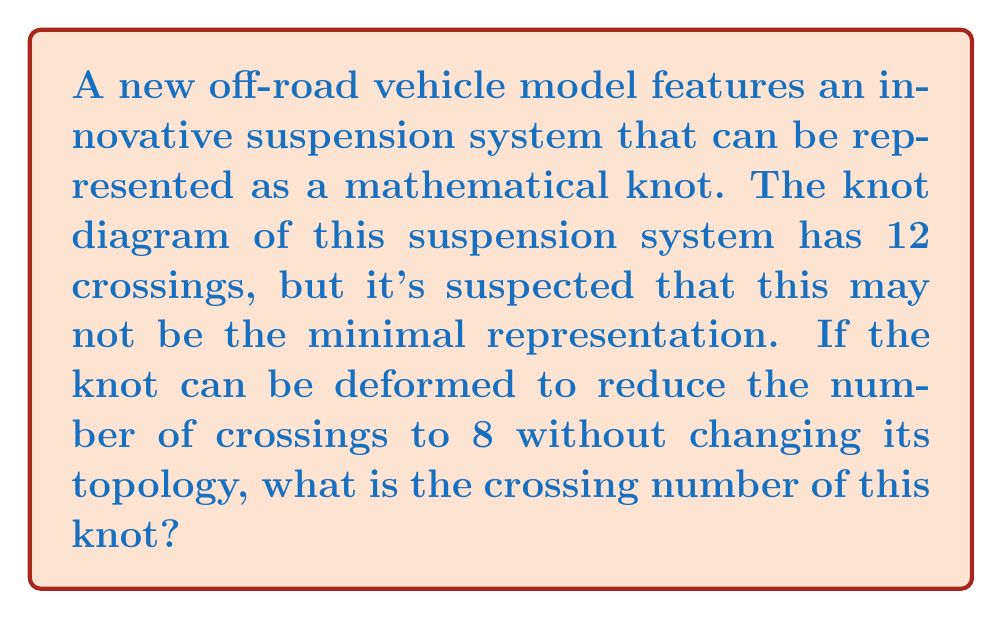Teach me how to tackle this problem. To determine the crossing number of the knot representing the off-road vehicle's suspension system, we need to follow these steps:

1. Understand the definition of crossing number:
   The crossing number of a knot is the minimum number of crossings that occur in any projection of the knot onto a plane.

2. Analyze the given information:
   - The initial knot diagram has 12 crossings.
   - The knot can be deformed to reduce the number of crossings to 8.

3. Apply the principle of minimal representation:
   The crossing number is always the smallest possible number of crossings that can be achieved through any deformation of the knot without changing its topology.

4. Compare the given crossing numbers:
   $$\text{Initial crossings} = 12$$
   $$\text{Reduced crossings} = 8$$

5. Determine the crossing number:
   Since the knot can be deformed to have 8 crossings, and this is smaller than the initial 12 crossings, the crossing number must be less than or equal to 8.

6. Consider potential further reductions:
   Without additional information, we cannot assume that the knot can be further simplified beyond 8 crossings. Therefore, 8 is the minimal known representation.

7. Conclude:
   The crossing number of the knot representing the suspension system is 8.
Answer: 8 